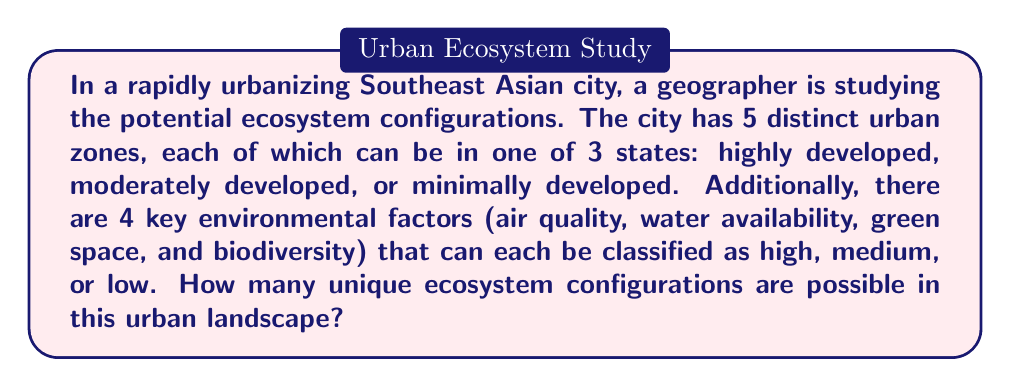Give your solution to this math problem. Let's approach this step-by-step:

1) First, let's consider the urban zones:
   - There are 5 distinct zones
   - Each zone can be in one of 3 states
   - This is a case of independent choices for each zone
   - The number of possibilities for the urban zones is therefore $3^5$

2) Now, let's consider the environmental factors:
   - There are 4 environmental factors
   - Each factor can be in one of 3 states
   - Again, this is a case of independent choices for each factor
   - The number of possibilities for the environmental factors is $3^4$

3) To get the total number of unique ecosystem configurations, we need to combine these possibilities:
   - Each possible combination of urban zone states can occur with each possible combination of environmental factor states
   - Therefore, we multiply the number of possibilities:

   $$(3^5) \cdot (3^4)$$

4) Let's calculate this:
   $$(3^5) \cdot (3^4) = 243 \cdot 81 = 19,683$$

Thus, there are 19,683 unique ecosystem configurations possible in this urban landscape.
Answer: 19,683 